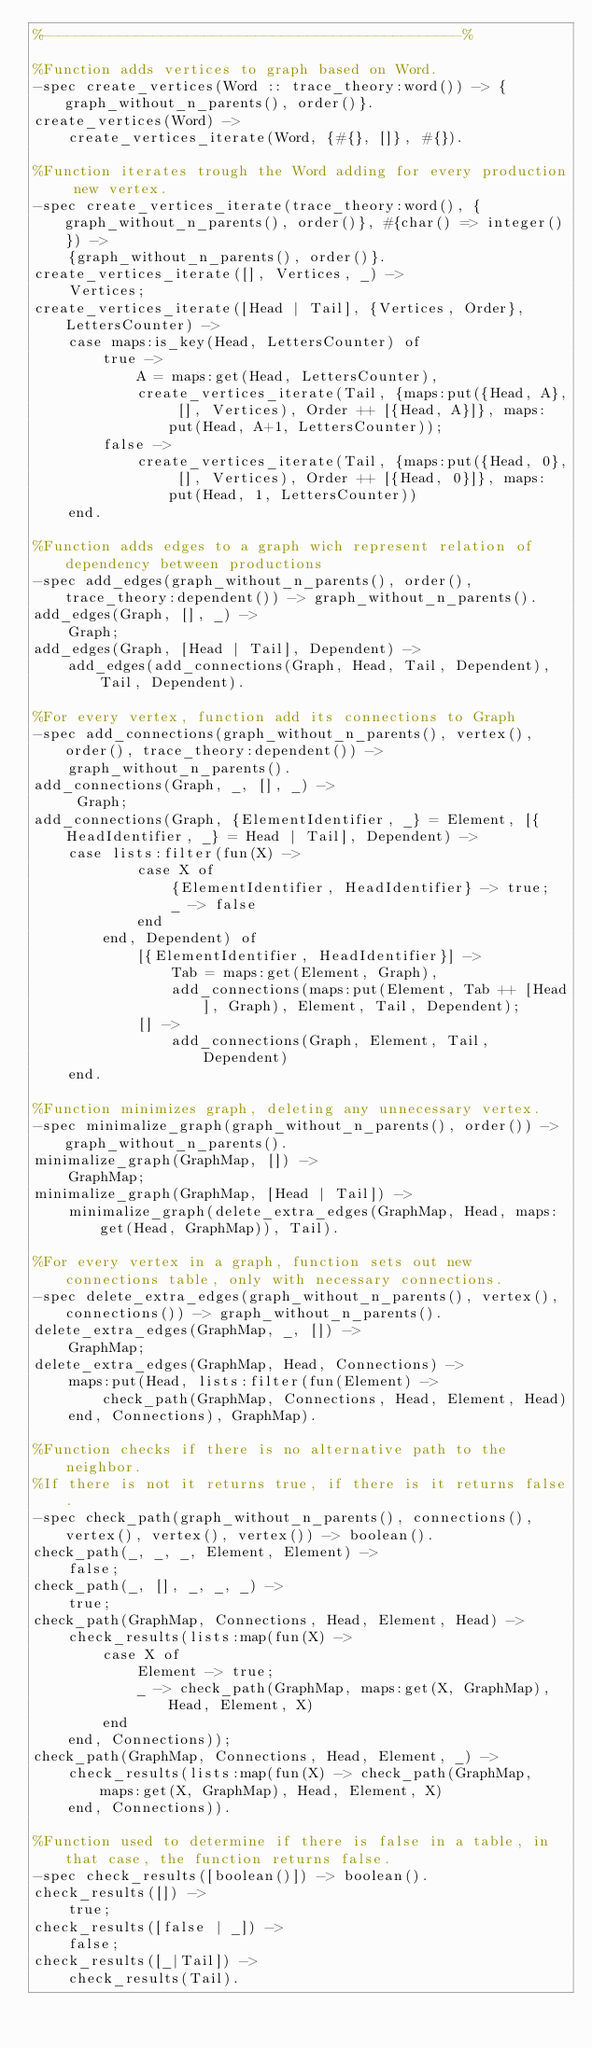Convert code to text. <code><loc_0><loc_0><loc_500><loc_500><_Erlang_>%-------------------------------------------------%

%Function adds vertices to graph based on Word.
-spec create_vertices(Word :: trace_theory:word()) -> {graph_without_n_parents(), order()}.
create_vertices(Word) ->
    create_vertices_iterate(Word, {#{}, []}, #{}).

%Function iterates trough the Word adding for every production new vertex.
-spec create_vertices_iterate(trace_theory:word(), {graph_without_n_parents(), order()}, #{char() => integer()}) ->
    {graph_without_n_parents(), order()}.
create_vertices_iterate([], Vertices, _) ->
    Vertices;
create_vertices_iterate([Head | Tail], {Vertices, Order}, LettersCounter) ->
    case maps:is_key(Head, LettersCounter) of
        true -> 
            A = maps:get(Head, LettersCounter),
            create_vertices_iterate(Tail, {maps:put({Head, A}, [], Vertices), Order ++ [{Head, A}]}, maps:put(Head, A+1, LettersCounter));
        false ->
            create_vertices_iterate(Tail, {maps:put({Head, 0}, [], Vertices), Order ++ [{Head, 0}]}, maps:put(Head, 1, LettersCounter))
    end.

%Function adds edges to a graph wich represent relation of dependency between productions
-spec add_edges(graph_without_n_parents(), order(), trace_theory:dependent()) -> graph_without_n_parents().
add_edges(Graph, [], _) ->
    Graph;
add_edges(Graph, [Head | Tail], Dependent) ->
    add_edges(add_connections(Graph, Head, Tail, Dependent), Tail, Dependent).

%For every vertex, function add its connections to Graph
-spec add_connections(graph_without_n_parents(), vertex(), order(), trace_theory:dependent()) ->
    graph_without_n_parents().
add_connections(Graph, _, [], _) ->
     Graph;
add_connections(Graph, {ElementIdentifier, _} = Element, [{HeadIdentifier, _} = Head | Tail], Dependent) ->
    case lists:filter(fun(X) ->
            case X of
                {ElementIdentifier, HeadIdentifier} -> true;
                _ -> false
            end
        end, Dependent) of 
            [{ElementIdentifier, HeadIdentifier}] -> 
                Tab = maps:get(Element, Graph),
                add_connections(maps:put(Element, Tab ++ [Head], Graph), Element, Tail, Dependent);
            [] -> 
                add_connections(Graph, Element, Tail, Dependent)
    end.

%Function minimizes graph, deleting any unnecessary vertex.
-spec minimalize_graph(graph_without_n_parents(), order()) -> graph_without_n_parents().
minimalize_graph(GraphMap, []) ->
    GraphMap;
minimalize_graph(GraphMap, [Head | Tail]) ->
    minimalize_graph(delete_extra_edges(GraphMap, Head, maps:get(Head, GraphMap)), Tail).

%For every vertex in a graph, function sets out new connections table, only with necessary connections.
-spec delete_extra_edges(graph_without_n_parents(), vertex(), connections()) -> graph_without_n_parents().
delete_extra_edges(GraphMap, _, []) ->
    GraphMap;
delete_extra_edges(GraphMap, Head, Connections) ->
    maps:put(Head, lists:filter(fun(Element) ->
        check_path(GraphMap, Connections, Head, Element, Head)
    end, Connections), GraphMap).

%Function checks if there is no alternative path to the neighbor.
%If there is not it returns true, if there is it returns false.
-spec check_path(graph_without_n_parents(), connections(), vertex(), vertex(), vertex()) -> boolean().
check_path(_, _, _, Element, Element) ->
    false;
check_path(_, [], _, _, _) ->
    true;
check_path(GraphMap, Connections, Head, Element, Head) ->
    check_results(lists:map(fun(X) -> 
        case X of
            Element -> true;
            _ -> check_path(GraphMap, maps:get(X, GraphMap), Head, Element, X)
        end
    end, Connections));
check_path(GraphMap, Connections, Head, Element, _) ->
    check_results(lists:map(fun(X) -> check_path(GraphMap, maps:get(X, GraphMap), Head, Element, X)
    end, Connections)).

%Function used to determine if there is false in a table, in that case, the function returns false.
-spec check_results([boolean()]) -> boolean().
check_results([]) ->
    true;
check_results([false | _]) ->
    false;
check_results([_|Tail]) ->
    check_results(Tail).
</code> 